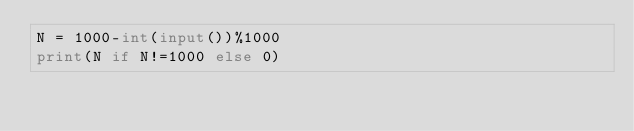Convert code to text. <code><loc_0><loc_0><loc_500><loc_500><_Python_>N = 1000-int(input())%1000
print(N if N!=1000 else 0)</code> 